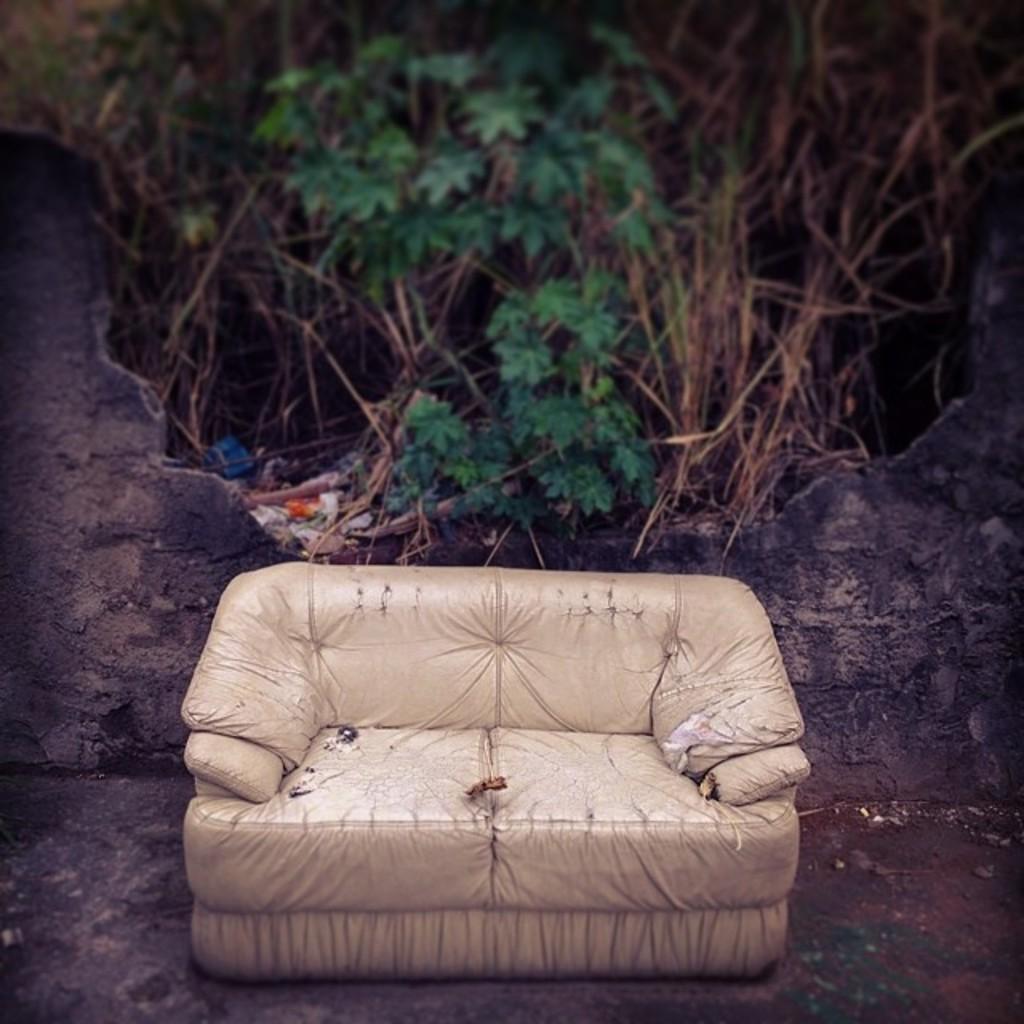Please provide a concise description of this image. In this picture we can see a couch in the front, in the background there are some trees and leaves, we can see some garbage in the middle, on the left side there is a wall. 